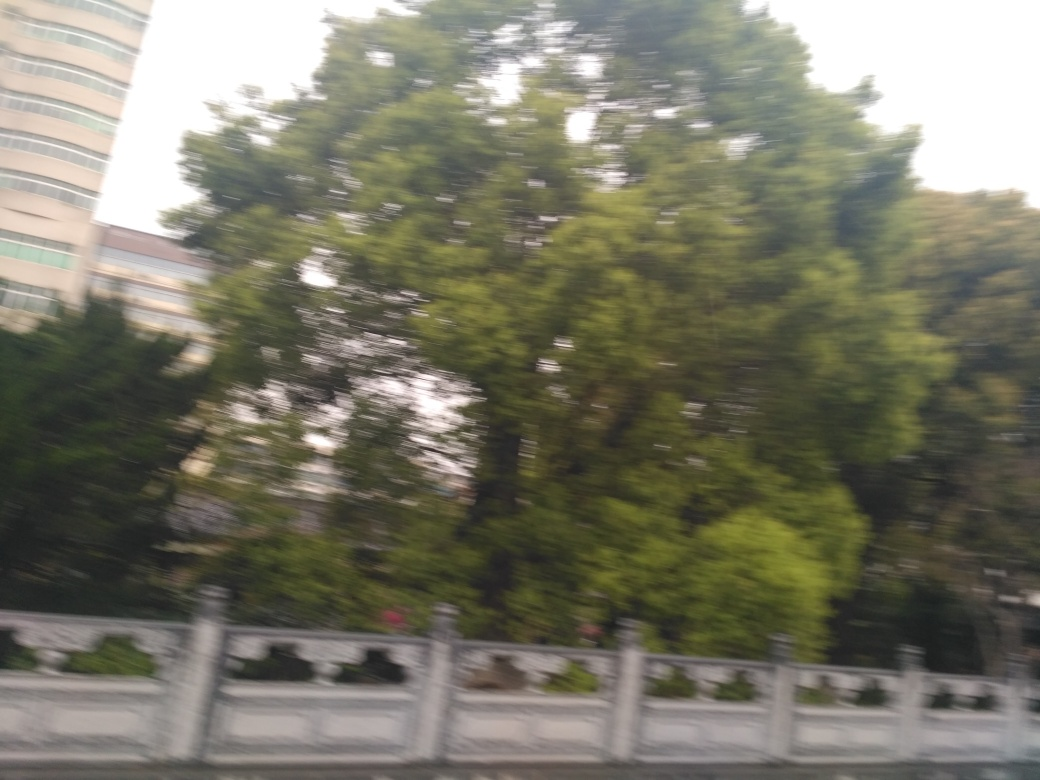What might be the significance of the guardrail in this image? The presence of the guardrail in the image plays a crucial role in terms of safety, delineating the boundary of the road and providing a protective barrier between vehicles and the natural area beside the road. It is a common sight on roadways near natural or developed areas and is designed to minimize the risk of accidents. 